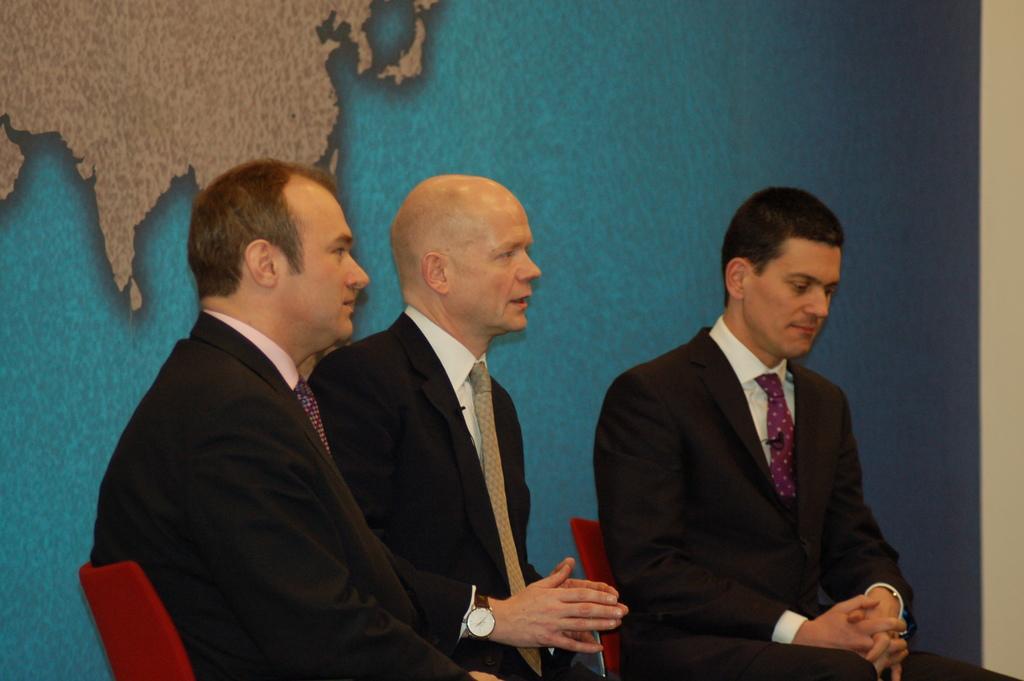Please provide a concise description of this image. In this image we can see there are three persons sitting on the chair and looking to the left side of the image. 